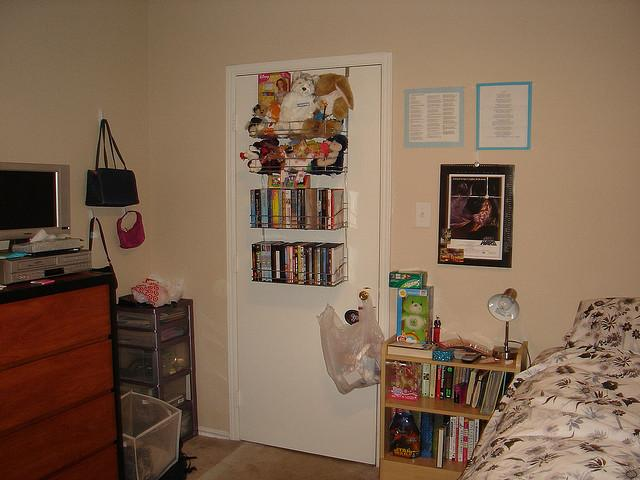What is the plastic bag on the door handle being used to collect?

Choices:
A) baseball cards
B) food
C) laundry
D) garbage garbage 